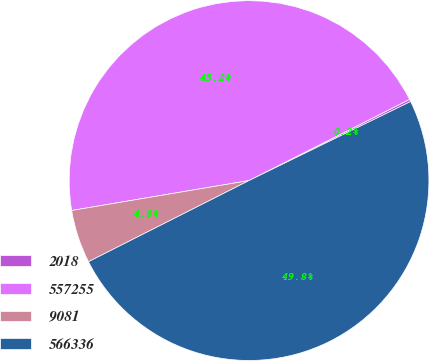<chart> <loc_0><loc_0><loc_500><loc_500><pie_chart><fcel>2018<fcel>557255<fcel>9081<fcel>566336<nl><fcel>0.21%<fcel>45.21%<fcel>4.79%<fcel>49.79%<nl></chart> 